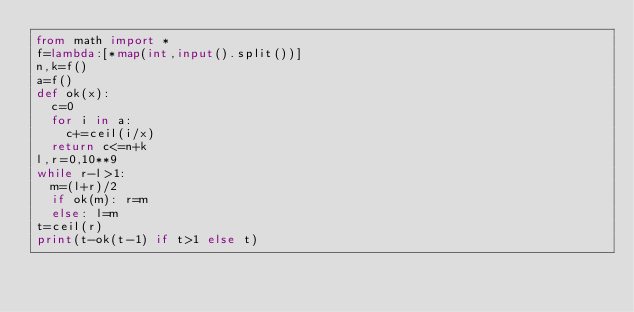Convert code to text. <code><loc_0><loc_0><loc_500><loc_500><_Python_>from math import *
f=lambda:[*map(int,input().split())]
n,k=f()
a=f()
def ok(x):
  c=0
  for i in a:
    c+=ceil(i/x)
  return c<=n+k
l,r=0,10**9
while r-l>1:
  m=(l+r)/2
  if ok(m): r=m
  else: l=m
t=ceil(r)
print(t-ok(t-1) if t>1 else t)</code> 